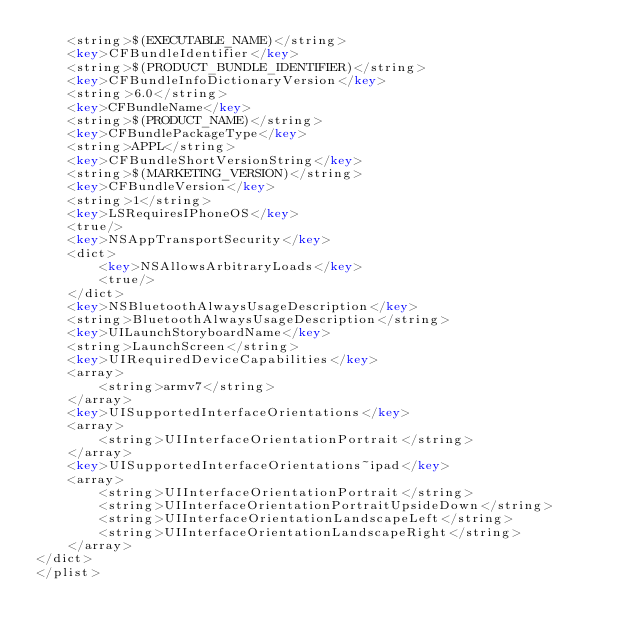Convert code to text. <code><loc_0><loc_0><loc_500><loc_500><_XML_>	<string>$(EXECUTABLE_NAME)</string>
	<key>CFBundleIdentifier</key>
	<string>$(PRODUCT_BUNDLE_IDENTIFIER)</string>
	<key>CFBundleInfoDictionaryVersion</key>
	<string>6.0</string>
	<key>CFBundleName</key>
	<string>$(PRODUCT_NAME)</string>
	<key>CFBundlePackageType</key>
	<string>APPL</string>
	<key>CFBundleShortVersionString</key>
	<string>$(MARKETING_VERSION)</string>
	<key>CFBundleVersion</key>
	<string>1</string>
	<key>LSRequiresIPhoneOS</key>
	<true/>
	<key>NSAppTransportSecurity</key>
	<dict>
		<key>NSAllowsArbitraryLoads</key>
		<true/>
	</dict>
	<key>NSBluetoothAlwaysUsageDescription</key>
	<string>BluetoothAlwaysUsageDescription</string>
	<key>UILaunchStoryboardName</key>
	<string>LaunchScreen</string>
	<key>UIRequiredDeviceCapabilities</key>
	<array>
		<string>armv7</string>
	</array>
	<key>UISupportedInterfaceOrientations</key>
	<array>
		<string>UIInterfaceOrientationPortrait</string>
	</array>
	<key>UISupportedInterfaceOrientations~ipad</key>
	<array>
		<string>UIInterfaceOrientationPortrait</string>
		<string>UIInterfaceOrientationPortraitUpsideDown</string>
		<string>UIInterfaceOrientationLandscapeLeft</string>
		<string>UIInterfaceOrientationLandscapeRight</string>
	</array>
</dict>
</plist>
</code> 